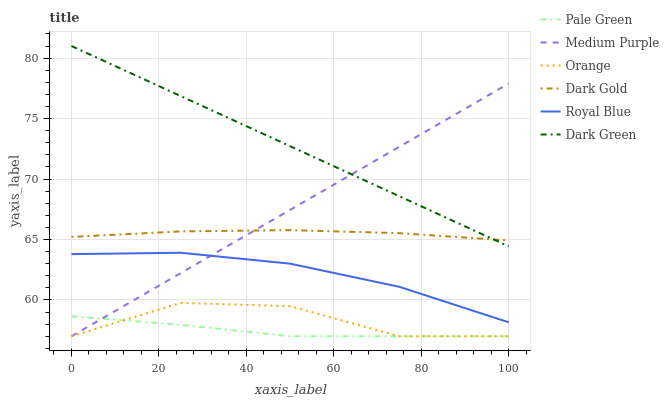Does Pale Green have the minimum area under the curve?
Answer yes or no. Yes. Does Dark Green have the maximum area under the curve?
Answer yes or no. Yes. Does Medium Purple have the minimum area under the curve?
Answer yes or no. No. Does Medium Purple have the maximum area under the curve?
Answer yes or no. No. Is Medium Purple the smoothest?
Answer yes or no. Yes. Is Orange the roughest?
Answer yes or no. Yes. Is Royal Blue the smoothest?
Answer yes or no. No. Is Royal Blue the roughest?
Answer yes or no. No. Does Royal Blue have the lowest value?
Answer yes or no. No. Does Dark Green have the highest value?
Answer yes or no. Yes. Does Medium Purple have the highest value?
Answer yes or no. No. Is Pale Green less than Dark Gold?
Answer yes or no. Yes. Is Dark Gold greater than Orange?
Answer yes or no. Yes. Does Dark Green intersect Dark Gold?
Answer yes or no. Yes. Is Dark Green less than Dark Gold?
Answer yes or no. No. Is Dark Green greater than Dark Gold?
Answer yes or no. No. Does Pale Green intersect Dark Gold?
Answer yes or no. No. 